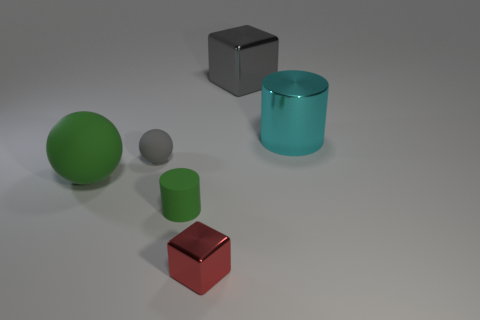There is a matte object in front of the green thing on the left side of the gray rubber thing; what color is it?
Provide a succinct answer. Green. Are there any metal cylinders of the same color as the small metal thing?
Make the answer very short. No. There is a gray thing right of the rubber object in front of the green object behind the tiny green rubber cylinder; how big is it?
Your answer should be compact. Large. Does the large cyan thing have the same shape as the gray thing left of the gray cube?
Give a very brief answer. No. What number of other objects are the same size as the green ball?
Offer a very short reply. 2. There is a rubber object that is behind the big matte object; what size is it?
Your answer should be compact. Small. What number of small red blocks have the same material as the big gray cube?
Your answer should be compact. 1. Is the shape of the big matte object that is on the left side of the small gray matte thing the same as  the small green object?
Your answer should be compact. No. There is a large object that is in front of the cyan metal thing; what is its shape?
Your answer should be very brief. Sphere. There is a cylinder that is the same color as the big rubber object; what size is it?
Give a very brief answer. Small. 